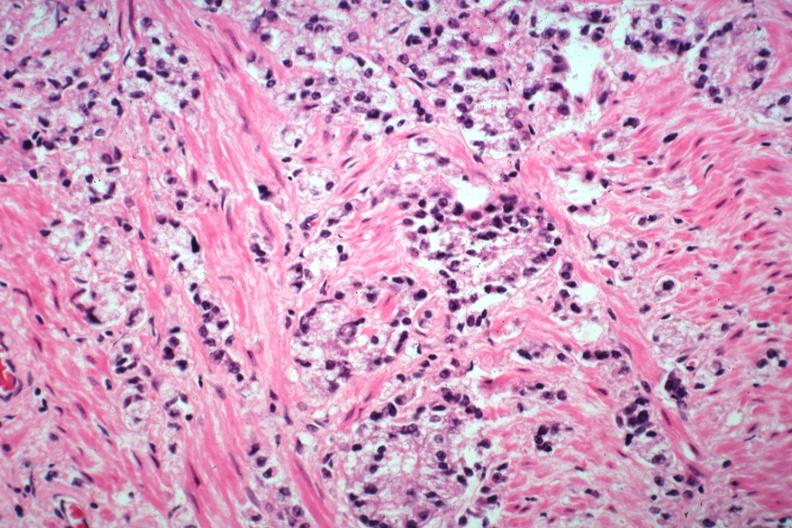does this image show typical infiltrating prostate carcinoma?
Answer the question using a single word or phrase. Yes 